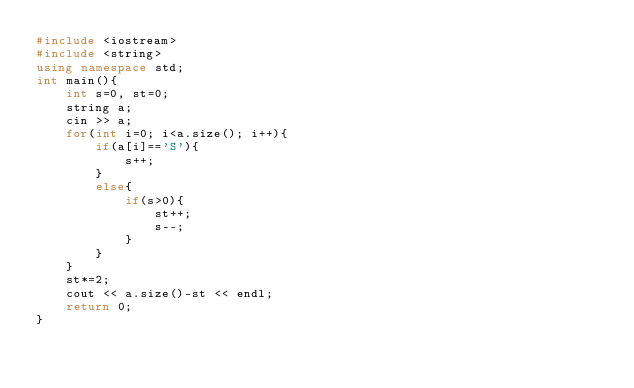Convert code to text. <code><loc_0><loc_0><loc_500><loc_500><_C++_>#include <iostream>
#include <string>
using namespace std;
int main(){
    int s=0, st=0;
    string a;
    cin >> a;
    for(int i=0; i<a.size(); i++){
        if(a[i]=='S'){
            s++;
        }
        else{
            if(s>0){
                st++;
                s--;
            }
        }
    }
    st*=2;
    cout << a.size()-st << endl;
    return 0;
}</code> 